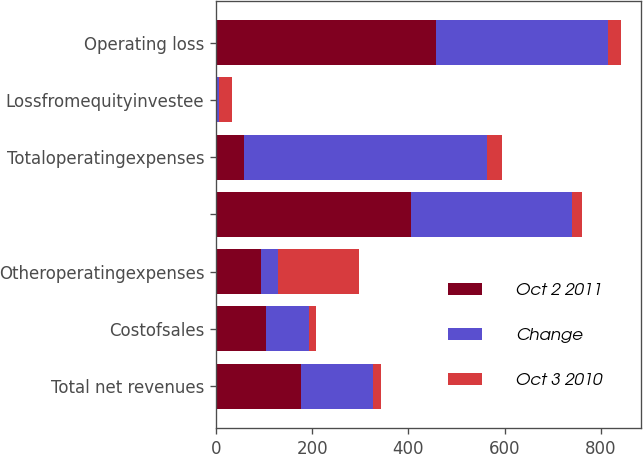Convert chart. <chart><loc_0><loc_0><loc_500><loc_500><stacked_bar_chart><ecel><fcel>Total net revenues<fcel>Costofsales<fcel>Otheroperatingexpenses<fcel>Unnamed: 4<fcel>Totaloperatingexpenses<fcel>Lossfromequityinvestee<fcel>Operating loss<nl><fcel>Oct 2 2011<fcel>175.8<fcel>103.1<fcel>93.5<fcel>405.2<fcel>58.6<fcel>2.4<fcel>456.8<nl><fcel>Change<fcel>150.8<fcel>89.4<fcel>34.9<fcel>334.1<fcel>505.8<fcel>3.3<fcel>358.3<nl><fcel>Oct 3 2010<fcel>16.6<fcel>15.3<fcel>167.9<fcel>21.3<fcel>30.6<fcel>27.3<fcel>27.5<nl></chart> 